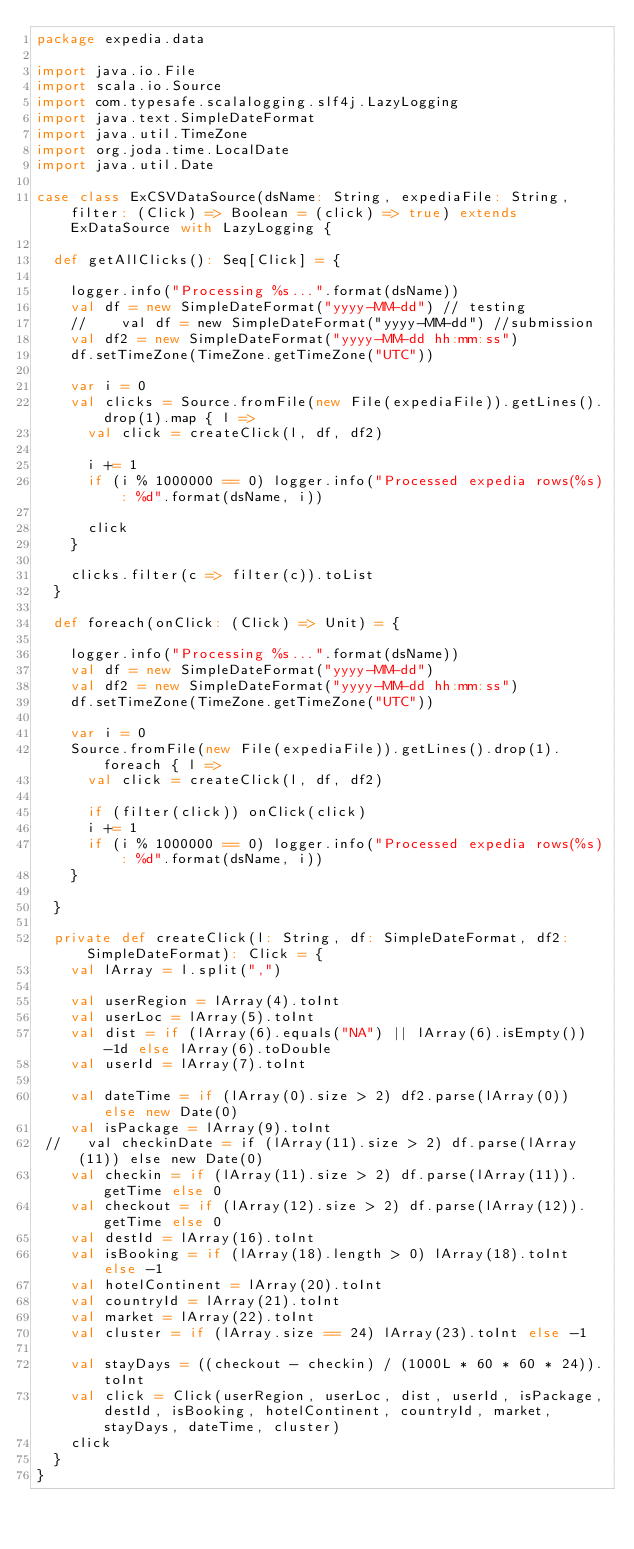<code> <loc_0><loc_0><loc_500><loc_500><_Scala_>package expedia.data

import java.io.File
import scala.io.Source
import com.typesafe.scalalogging.slf4j.LazyLogging
import java.text.SimpleDateFormat
import java.util.TimeZone
import org.joda.time.LocalDate
import java.util.Date

case class ExCSVDataSource(dsName: String, expediaFile: String, filter: (Click) => Boolean = (click) => true) extends ExDataSource with LazyLogging {

  def getAllClicks(): Seq[Click] = {

    logger.info("Processing %s...".format(dsName))
    val df = new SimpleDateFormat("yyyy-MM-dd") // testing
    //    val df = new SimpleDateFormat("yyyy-MM-dd") //submission
    val df2 = new SimpleDateFormat("yyyy-MM-dd hh:mm:ss")
    df.setTimeZone(TimeZone.getTimeZone("UTC"))

    var i = 0
    val clicks = Source.fromFile(new File(expediaFile)).getLines().drop(1).map { l =>
      val click = createClick(l, df, df2)

      i += 1
      if (i % 1000000 == 0) logger.info("Processed expedia rows(%s): %d".format(dsName, i))

      click
    }

    clicks.filter(c => filter(c)).toList
  }

  def foreach(onClick: (Click) => Unit) = {

    logger.info("Processing %s...".format(dsName))
    val df = new SimpleDateFormat("yyyy-MM-dd")
    val df2 = new SimpleDateFormat("yyyy-MM-dd hh:mm:ss")
    df.setTimeZone(TimeZone.getTimeZone("UTC"))

    var i = 0
    Source.fromFile(new File(expediaFile)).getLines().drop(1).foreach { l =>
      val click = createClick(l, df, df2)

      if (filter(click)) onClick(click)
      i += 1
      if (i % 1000000 == 0) logger.info("Processed expedia rows(%s): %d".format(dsName, i))
    }

  }

  private def createClick(l: String, df: SimpleDateFormat, df2: SimpleDateFormat): Click = {
    val lArray = l.split(",")

    val userRegion = lArray(4).toInt
    val userLoc = lArray(5).toInt
    val dist = if (lArray(6).equals("NA") || lArray(6).isEmpty()) -1d else lArray(6).toDouble
    val userId = lArray(7).toInt

    val dateTime = if (lArray(0).size > 2) df2.parse(lArray(0)) else new Date(0)
    val isPackage = lArray(9).toInt
 //   val checkinDate = if (lArray(11).size > 2) df.parse(lArray(11)) else new Date(0)
    val checkin = if (lArray(11).size > 2) df.parse(lArray(11)).getTime else 0
    val checkout = if (lArray(12).size > 2) df.parse(lArray(12)).getTime else 0
    val destId = lArray(16).toInt
    val isBooking = if (lArray(18).length > 0) lArray(18).toInt else -1
    val hotelContinent = lArray(20).toInt
    val countryId = lArray(21).toInt
    val market = lArray(22).toInt
    val cluster = if (lArray.size == 24) lArray(23).toInt else -1

    val stayDays = ((checkout - checkin) / (1000L * 60 * 60 * 24)).toInt
    val click = Click(userRegion, userLoc, dist, userId, isPackage,destId, isBooking, hotelContinent, countryId, market, stayDays, dateTime, cluster)
    click
  }
}</code> 